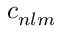Convert formula to latex. <formula><loc_0><loc_0><loc_500><loc_500>c _ { n l m }</formula> 